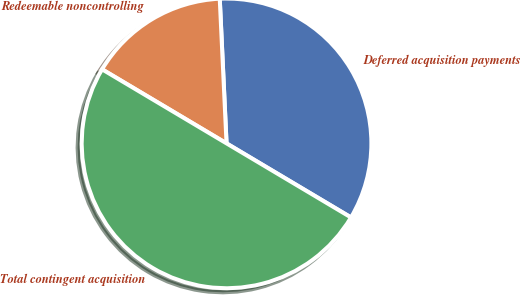Convert chart to OTSL. <chart><loc_0><loc_0><loc_500><loc_500><pie_chart><fcel>Deferred acquisition payments<fcel>Redeemable noncontrolling<fcel>Total contingent acquisition<nl><fcel>34.29%<fcel>15.71%<fcel>50.0%<nl></chart> 